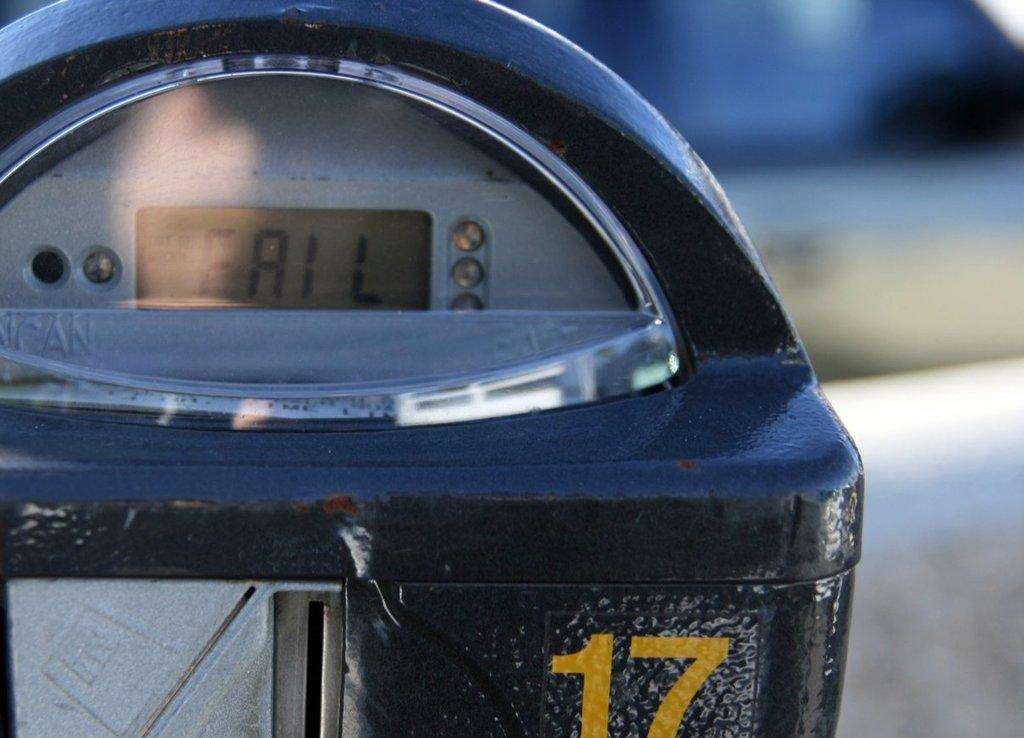Provide a one-sentence caption for the provided image. A fail sign has appeared on the parking meter labeled 17. 